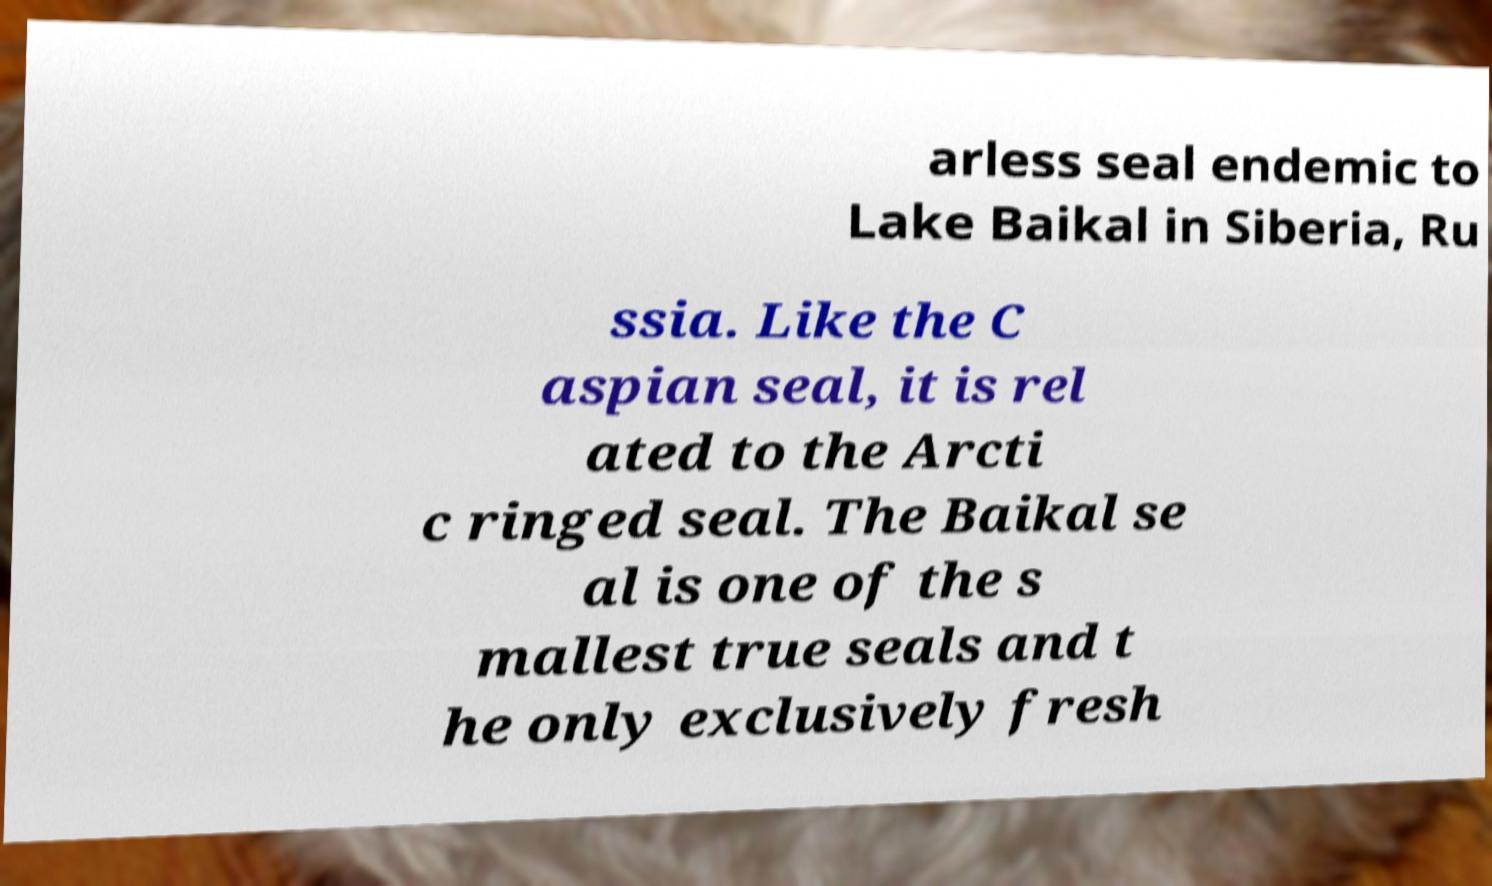Could you extract and type out the text from this image? arless seal endemic to Lake Baikal in Siberia, Ru ssia. Like the C aspian seal, it is rel ated to the Arcti c ringed seal. The Baikal se al is one of the s mallest true seals and t he only exclusively fresh 